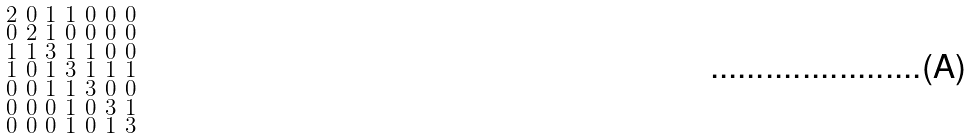<formula> <loc_0><loc_0><loc_500><loc_500>\begin{smallmatrix} 2 & 0 & 1 & 1 & 0 & 0 & 0 \\ 0 & 2 & 1 & 0 & 0 & 0 & 0 \\ 1 & 1 & 3 & 1 & 1 & 0 & 0 \\ 1 & 0 & 1 & 3 & 1 & 1 & 1 \\ 0 & 0 & 1 & 1 & 3 & 0 & 0 \\ 0 & 0 & 0 & 1 & 0 & 3 & 1 \\ 0 & 0 & 0 & 1 & 0 & 1 & 3 \end{smallmatrix}</formula> 